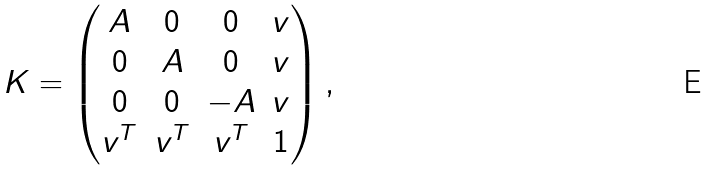Convert formula to latex. <formula><loc_0><loc_0><loc_500><loc_500>K = \left ( \begin{matrix} A & 0 & 0 & v \\ 0 & A & 0 & v \\ 0 & 0 & - A & v \\ v ^ { T } & v ^ { T } & v ^ { T } & 1 \\ \end{matrix} \right ) ,</formula> 